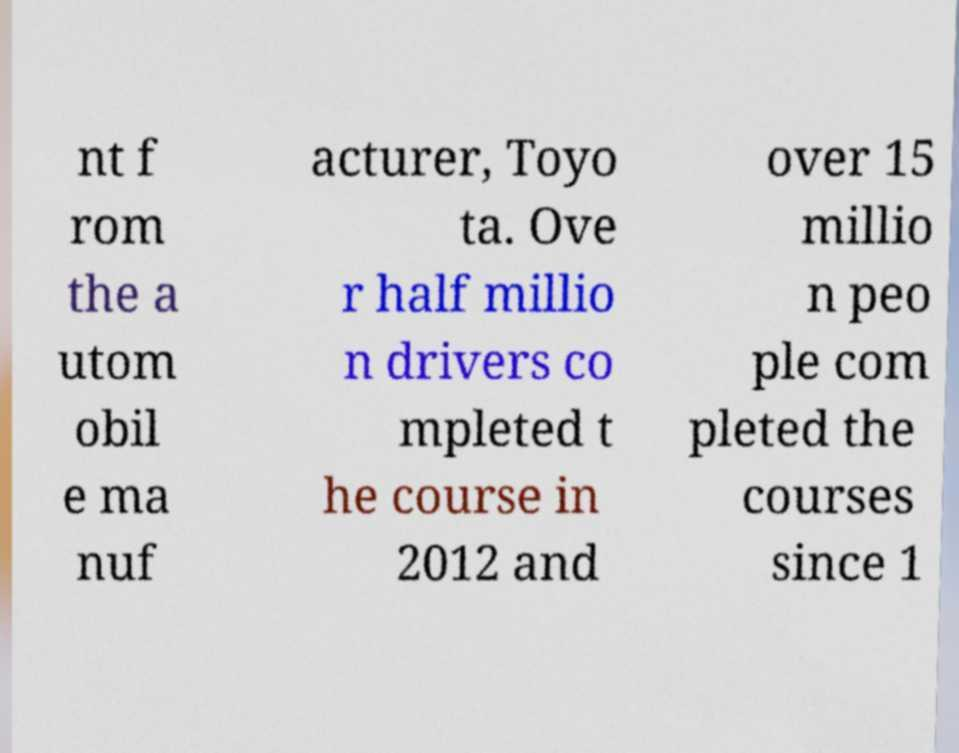What messages or text are displayed in this image? I need them in a readable, typed format. nt f rom the a utom obil e ma nuf acturer, Toyo ta. Ove r half millio n drivers co mpleted t he course in 2012 and over 15 millio n peo ple com pleted the courses since 1 